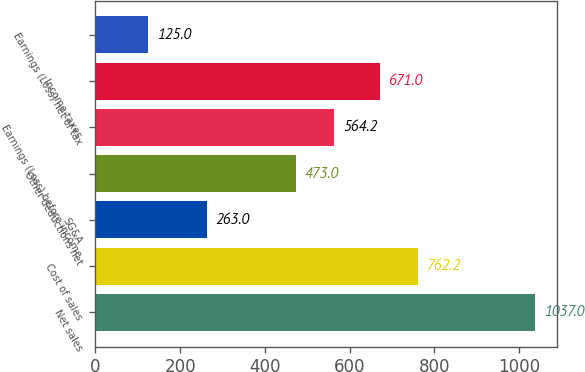Convert chart to OTSL. <chart><loc_0><loc_0><loc_500><loc_500><bar_chart><fcel>Net sales<fcel>Cost of sales<fcel>SG&A<fcel>Other deductions net<fcel>Earnings (Loss) before income<fcel>Income taxes<fcel>Earnings (Loss) net of tax<nl><fcel>1037<fcel>762.2<fcel>263<fcel>473<fcel>564.2<fcel>671<fcel>125<nl></chart> 